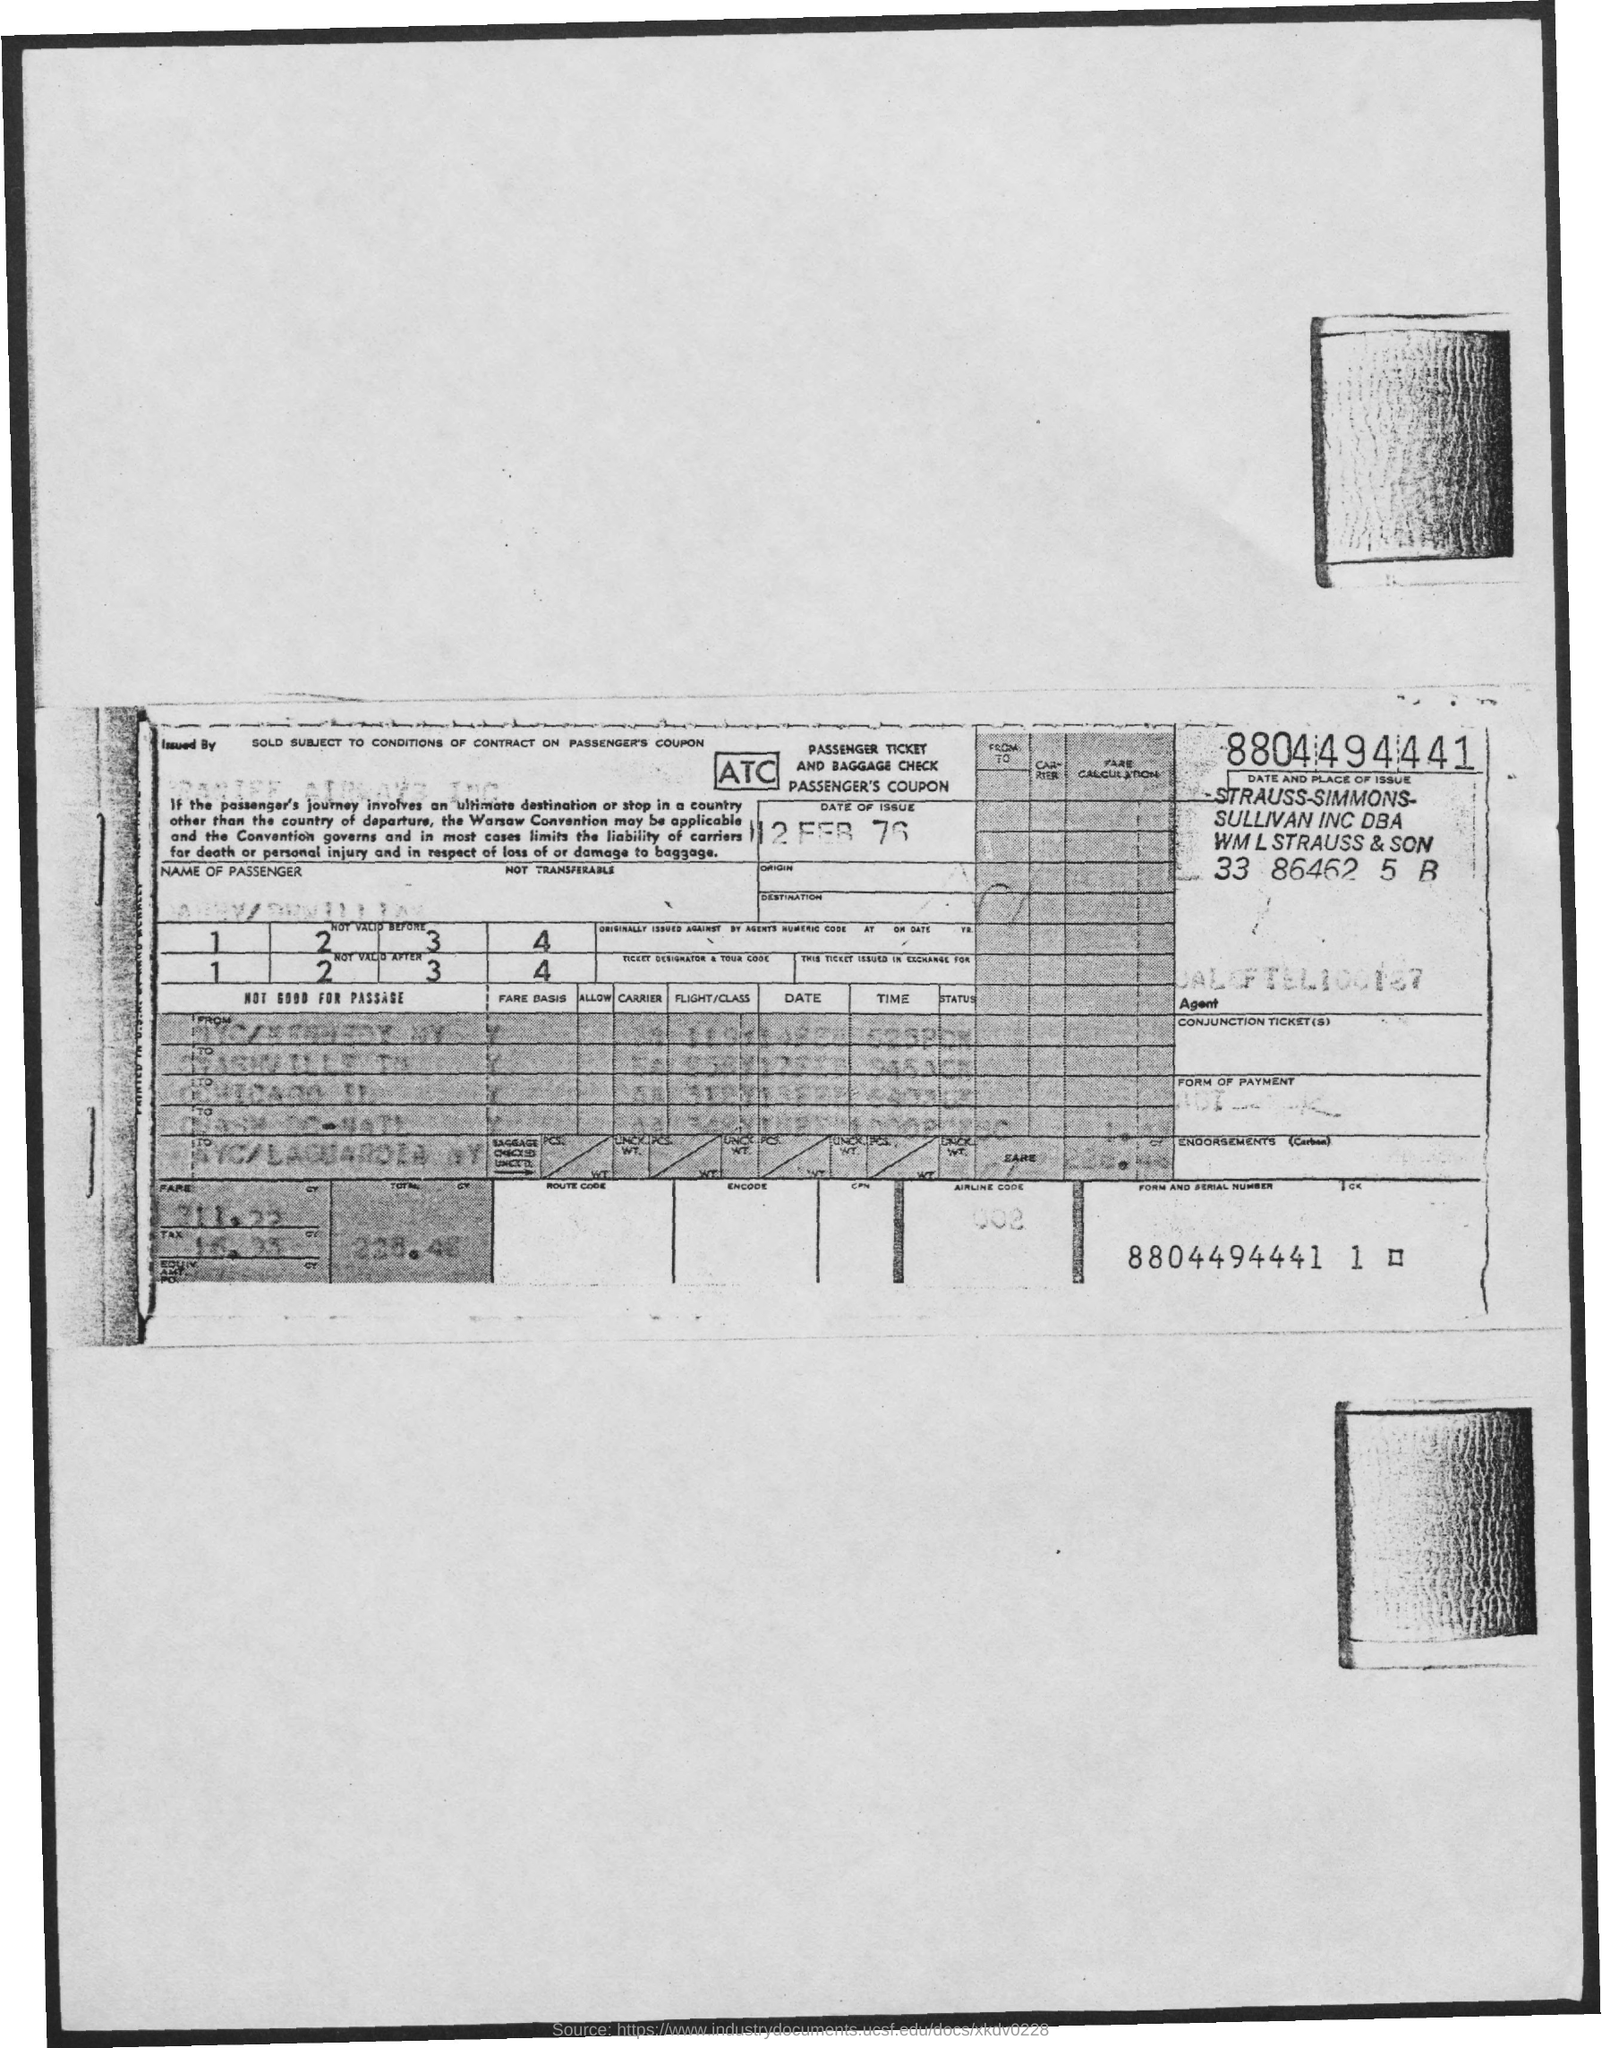What is the date of the issue?
Your answer should be very brief. 12 Feb 76. 